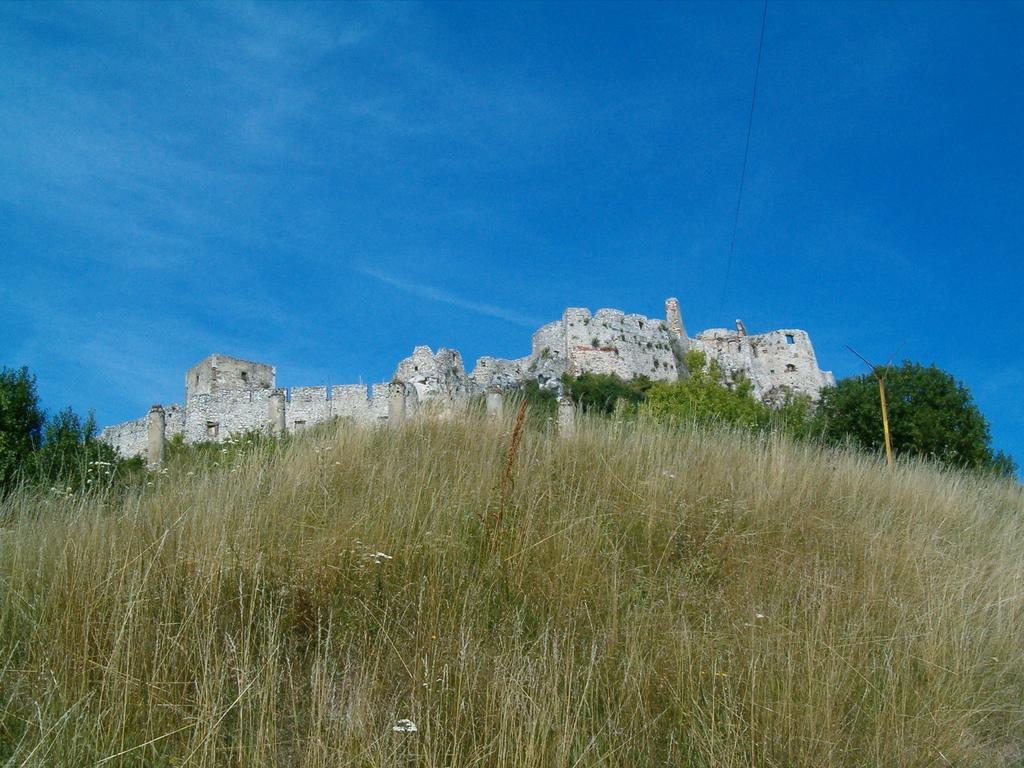In one or two sentences, can you explain what this image depicts? In the picture I can see grass, stone fort, trees and the blue color sky in the background. 